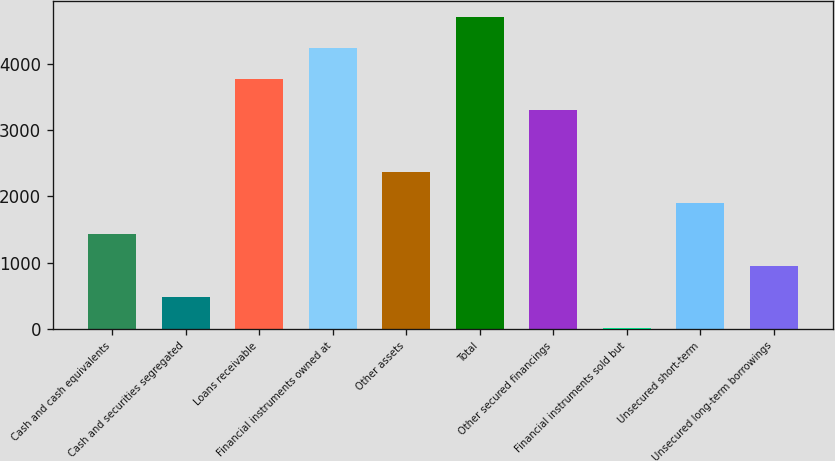Convert chart to OTSL. <chart><loc_0><loc_0><loc_500><loc_500><bar_chart><fcel>Cash and cash equivalents<fcel>Cash and securities segregated<fcel>Loans receivable<fcel>Financial instruments owned at<fcel>Other assets<fcel>Total<fcel>Other secured financings<fcel>Financial instruments sold but<fcel>Unsecured short-term<fcel>Unsecured long-term borrowings<nl><fcel>1424.8<fcel>485.6<fcel>3772.8<fcel>4242.4<fcel>2364<fcel>4712<fcel>3303.2<fcel>16<fcel>1894.4<fcel>955.2<nl></chart> 